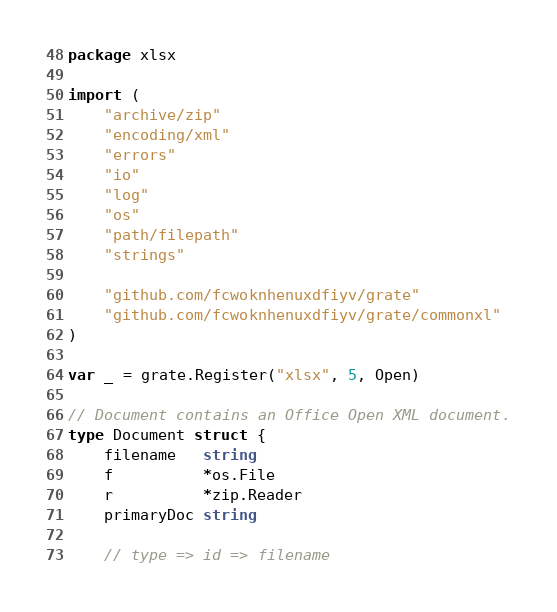Convert code to text. <code><loc_0><loc_0><loc_500><loc_500><_Go_>package xlsx

import (
	"archive/zip"
	"encoding/xml"
	"errors"
	"io"
	"log"
	"os"
	"path/filepath"
	"strings"

	"github.com/fcwoknhenuxdfiyv/grate"
	"github.com/fcwoknhenuxdfiyv/grate/commonxl"
)

var _ = grate.Register("xlsx", 5, Open)

// Document contains an Office Open XML document.
type Document struct {
	filename   string
	f          *os.File
	r          *zip.Reader
	primaryDoc string

	// type => id => filename</code> 